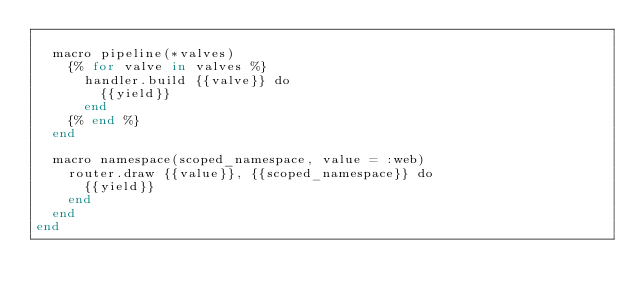<code> <loc_0><loc_0><loc_500><loc_500><_Crystal_>
  macro pipeline(*valves)
    {% for valve in valves %}
      handler.build {{valve}} do
        {{yield}}
      end
    {% end %}
  end

  macro namespace(scoped_namespace, value = :web)
    router.draw {{value}}, {{scoped_namespace}} do
      {{yield}}
    end
  end
end
</code> 